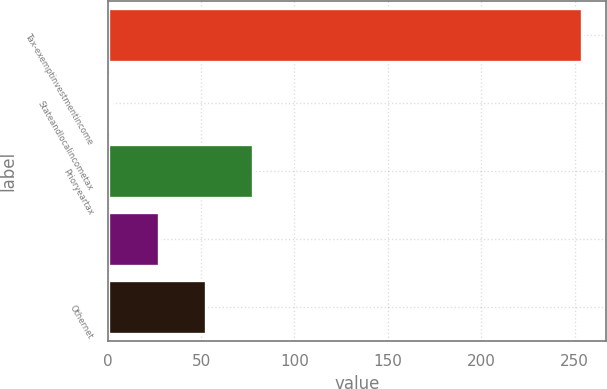Convert chart to OTSL. <chart><loc_0><loc_0><loc_500><loc_500><bar_chart><fcel>Tax-exemptinvestmentincome<fcel>Stateandlocalincometax<fcel>Prioryeartax<fcel>Unnamed: 3<fcel>Othernet<nl><fcel>254<fcel>2<fcel>77.6<fcel>27.2<fcel>52.4<nl></chart> 